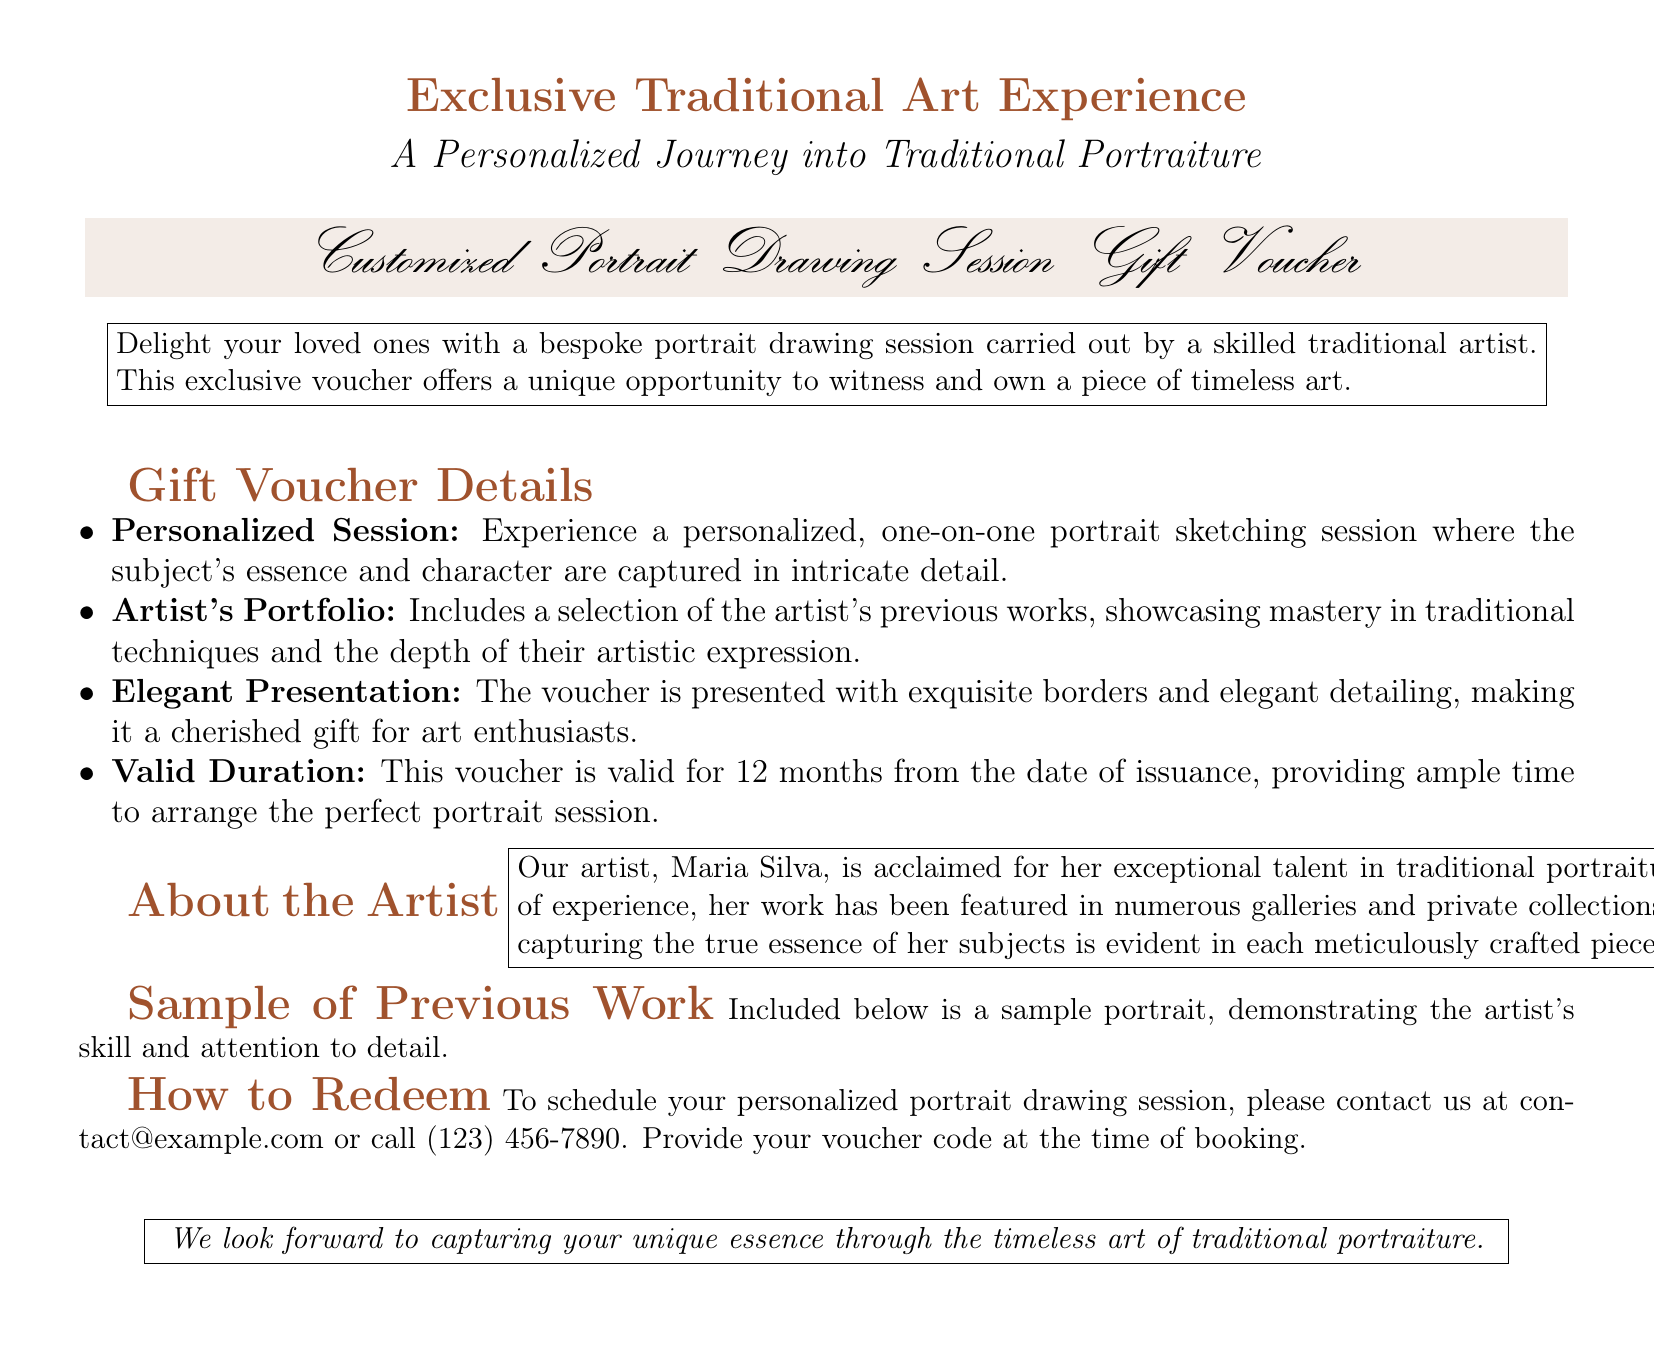what is the title of the voucher? The title of the voucher is prominently displayed as "Customized Portrait Drawing Session Gift Voucher."
Answer: Customized Portrait Drawing Session Gift Voucher who is the artist featured in the document? The document provides information about the artist as "Maria Silva."
Answer: Maria Silva how long is the voucher valid? The document states the validity period of the voucher as "12 months from the date of issuance."
Answer: 12 months what is included in the artist's portfolio? The document mentions that it includes "a selection of the artist's previous works."
Answer: a selection of the artist's previous works what is the primary offering of this gift voucher? According to the document, the primary offering is "a bespoke portrait drawing session."
Answer: a bespoke portrait drawing session what type of art does the voucher pertain to? The document specifies that it is related to "traditional portraiture."
Answer: traditional portraiture how can you schedule your session? The document mentions to "contact us at contact@example.com or call (123) 456-7890."
Answer: contact us at contact@example.com or call (123) 456-7890 what is the aim of the personalized session? The document states that the aim is to "capture the subject's essence and character."
Answer: capture the subject's essence and character 